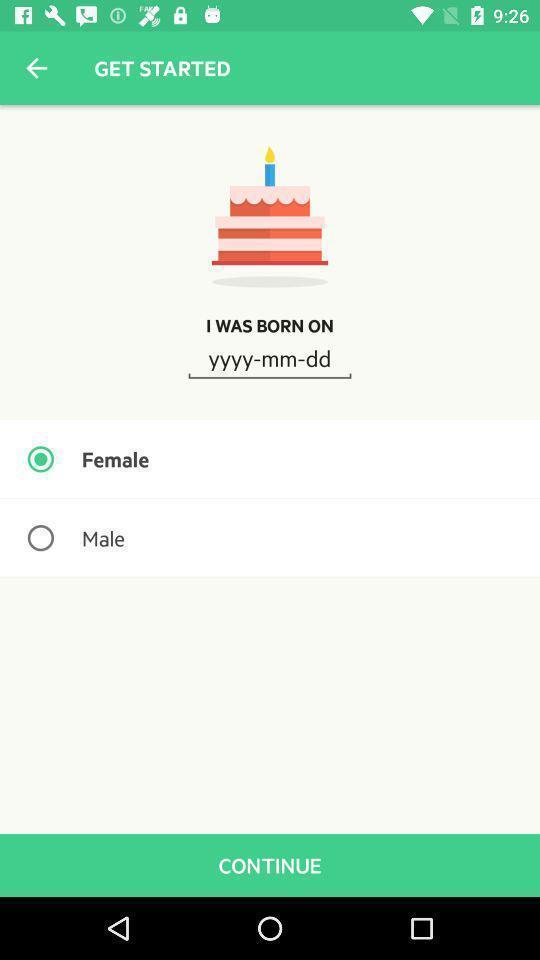Explain what's happening in this screen capture. Welcome page of a social app. 